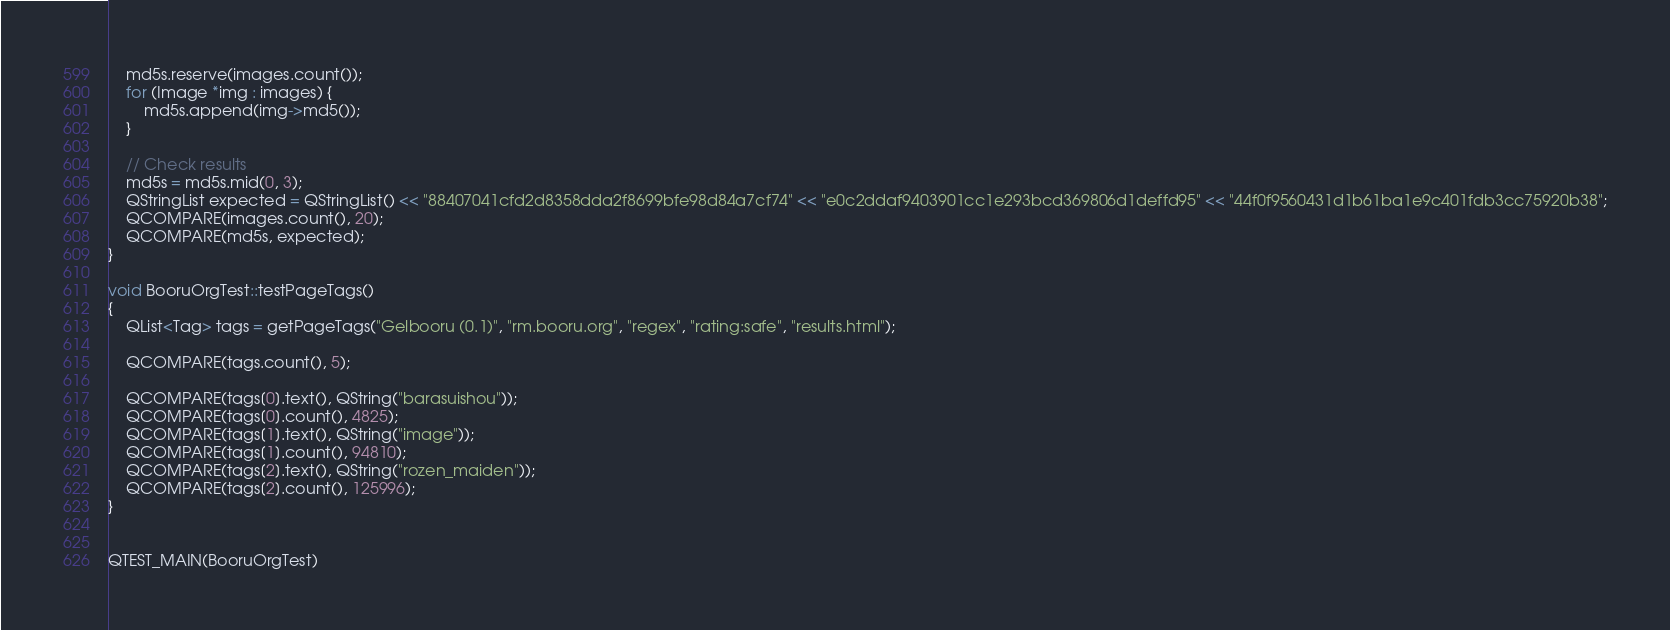<code> <loc_0><loc_0><loc_500><loc_500><_C++_>	md5s.reserve(images.count());
	for (Image *img : images) {
		md5s.append(img->md5());
	}

	// Check results
	md5s = md5s.mid(0, 3);
	QStringList expected = QStringList() << "88407041cfd2d8358dda2f8699bfe98d84a7cf74" << "e0c2ddaf9403901cc1e293bcd369806d1deffd95" << "44f0f9560431d1b61ba1e9c401fdb3cc75920b38";
	QCOMPARE(images.count(), 20);
	QCOMPARE(md5s, expected);
}

void BooruOrgTest::testPageTags()
{
	QList<Tag> tags = getPageTags("Gelbooru (0.1)", "rm.booru.org", "regex", "rating:safe", "results.html");

	QCOMPARE(tags.count(), 5);

	QCOMPARE(tags[0].text(), QString("barasuishou"));
	QCOMPARE(tags[0].count(), 4825);
	QCOMPARE(tags[1].text(), QString("image"));
	QCOMPARE(tags[1].count(), 94810);
	QCOMPARE(tags[2].text(), QString("rozen_maiden"));
	QCOMPARE(tags[2].count(), 125996);
}


QTEST_MAIN(BooruOrgTest)
</code> 